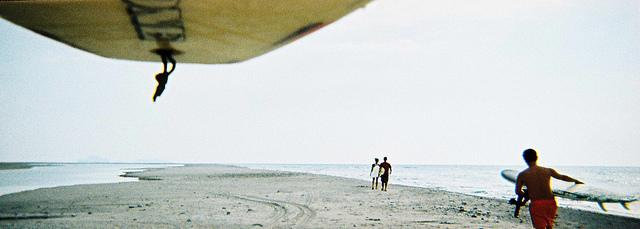How will the people here likely propel themselves upon waves?

Choices:
A) running
B) scuba diving
C) kiting
D) surfing surfing 